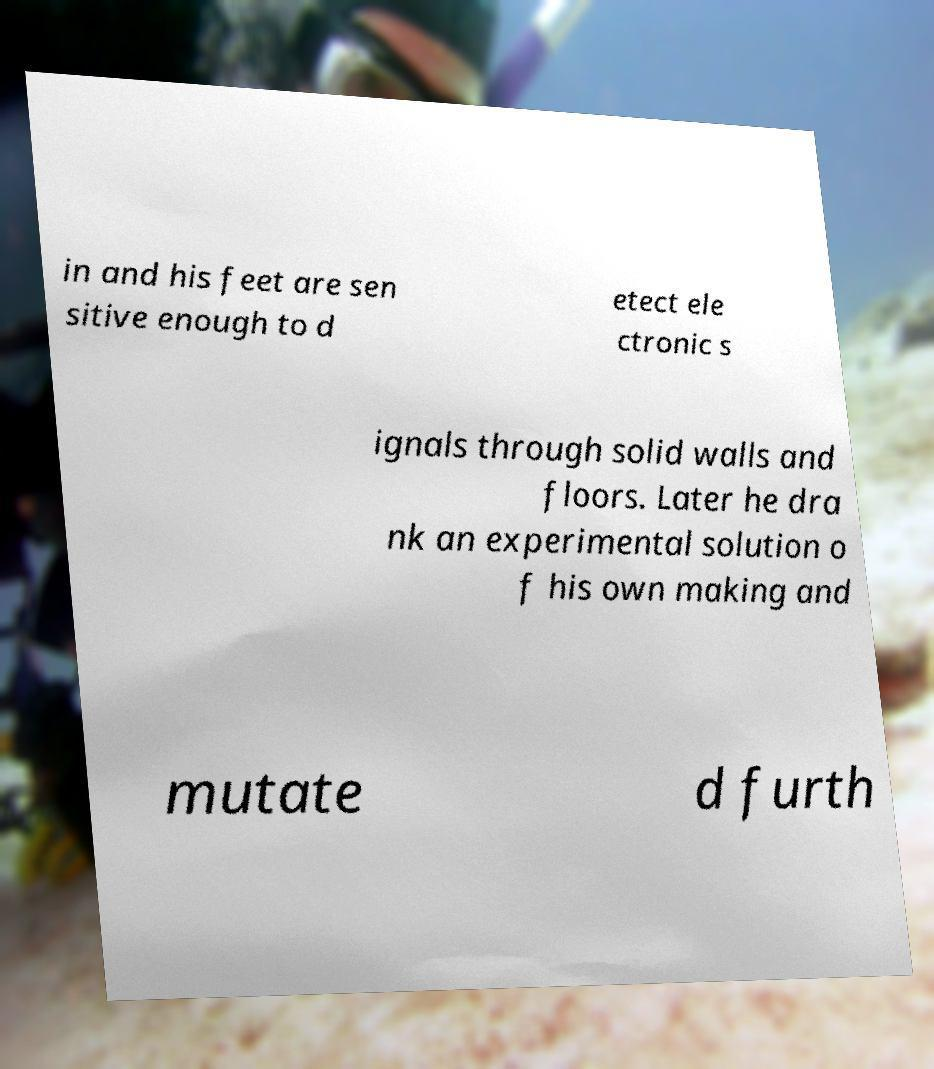Can you read and provide the text displayed in the image?This photo seems to have some interesting text. Can you extract and type it out for me? in and his feet are sen sitive enough to d etect ele ctronic s ignals through solid walls and floors. Later he dra nk an experimental solution o f his own making and mutate d furth 